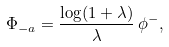<formula> <loc_0><loc_0><loc_500><loc_500>\Phi _ { - a } = \frac { \log ( 1 + \lambda ) } { \lambda } \, \phi ^ { - } ,</formula> 